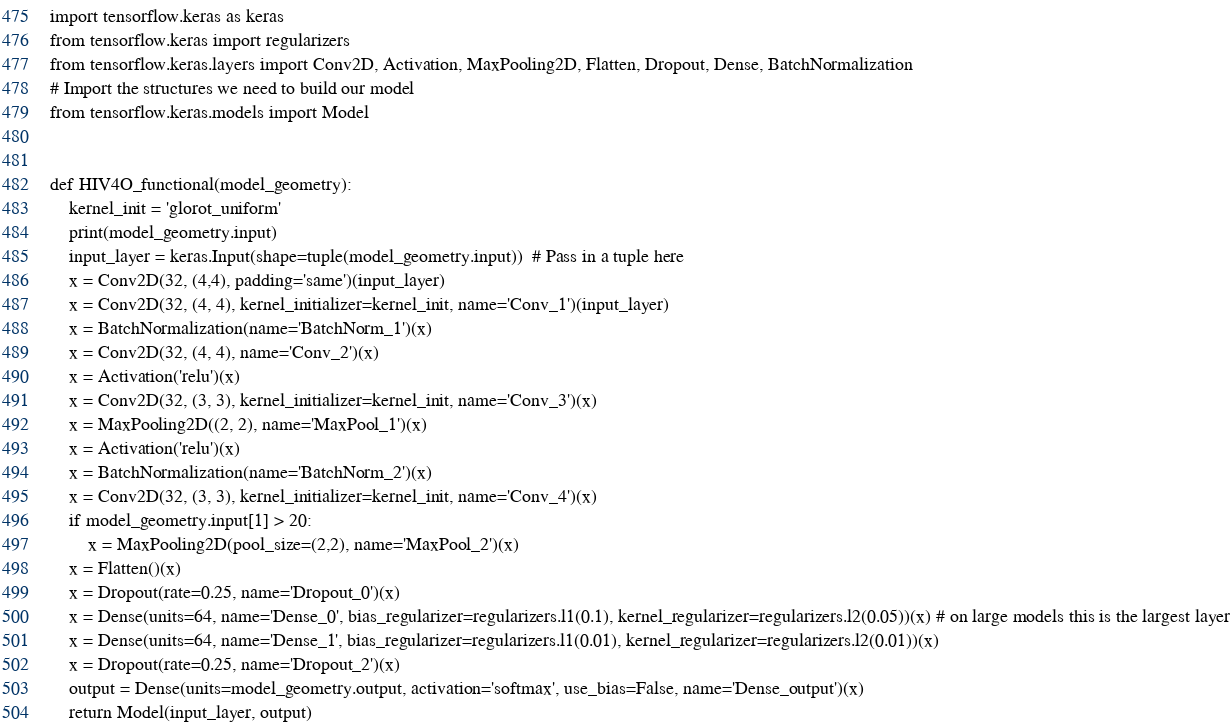Convert code to text. <code><loc_0><loc_0><loc_500><loc_500><_Python_>import tensorflow.keras as keras
from tensorflow.keras import regularizers
from tensorflow.keras.layers import Conv2D, Activation, MaxPooling2D, Flatten, Dropout, Dense, BatchNormalization
# Import the structures we need to build our model
from tensorflow.keras.models import Model


def HIV4O_functional(model_geometry):
    kernel_init = 'glorot_uniform'
    print(model_geometry.input)
    input_layer = keras.Input(shape=tuple(model_geometry.input))  # Pass in a tuple here
    x = Conv2D(32, (4,4), padding='same')(input_layer)
    x = Conv2D(32, (4, 4), kernel_initializer=kernel_init, name='Conv_1')(input_layer)
    x = BatchNormalization(name='BatchNorm_1')(x)   
    x = Conv2D(32, (4, 4), name='Conv_2')(x) 
    x = Activation('relu')(x)
    x = Conv2D(32, (3, 3), kernel_initializer=kernel_init, name='Conv_3')(x)
    x = MaxPooling2D((2, 2), name='MaxPool_1')(x)
    x = Activation('relu')(x)
    x = BatchNormalization(name='BatchNorm_2')(x)
    x = Conv2D(32, (3, 3), kernel_initializer=kernel_init, name='Conv_4')(x)
    if model_geometry.input[1] > 20:
        x = MaxPooling2D(pool_size=(2,2), name='MaxPool_2')(x)
    x = Flatten()(x)
    x = Dropout(rate=0.25, name='Dropout_0')(x)
    x = Dense(units=64, name='Dense_0', bias_regularizer=regularizers.l1(0.1), kernel_regularizer=regularizers.l2(0.05))(x) # on large models this is the largest layer
    x = Dense(units=64, name='Dense_1', bias_regularizer=regularizers.l1(0.01), kernel_regularizer=regularizers.l2(0.01))(x)
    x = Dropout(rate=0.25, name='Dropout_2')(x)
    output = Dense(units=model_geometry.output, activation='softmax', use_bias=False, name='Dense_output')(x)
    return Model(input_layer, output)
</code> 